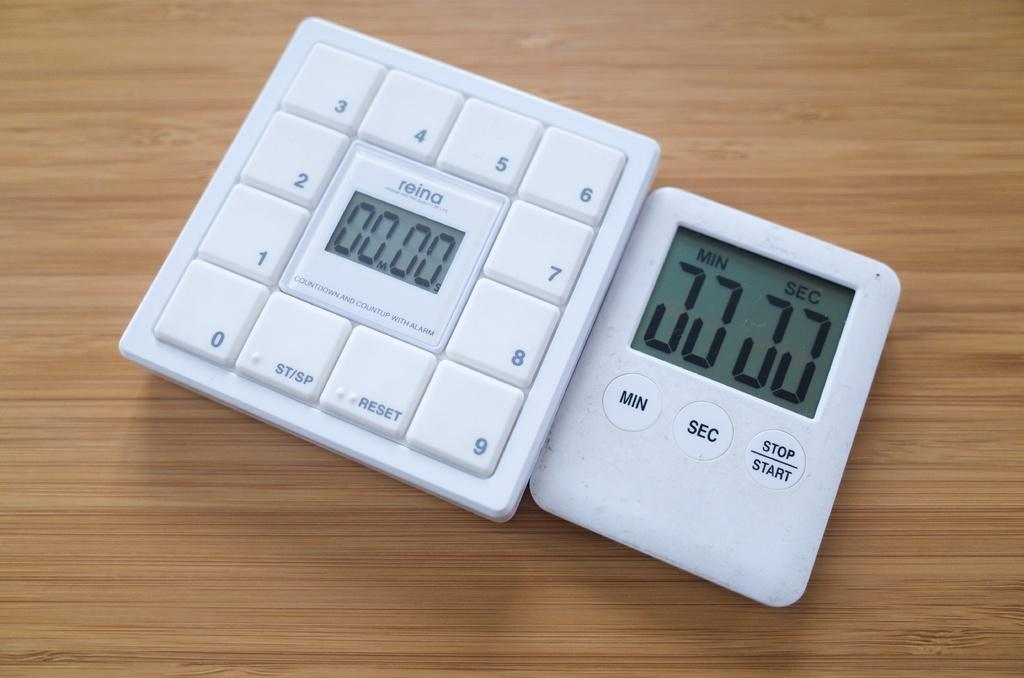<image>
Give a short and clear explanation of the subsequent image. A calculator next a stop watch both reading 0 